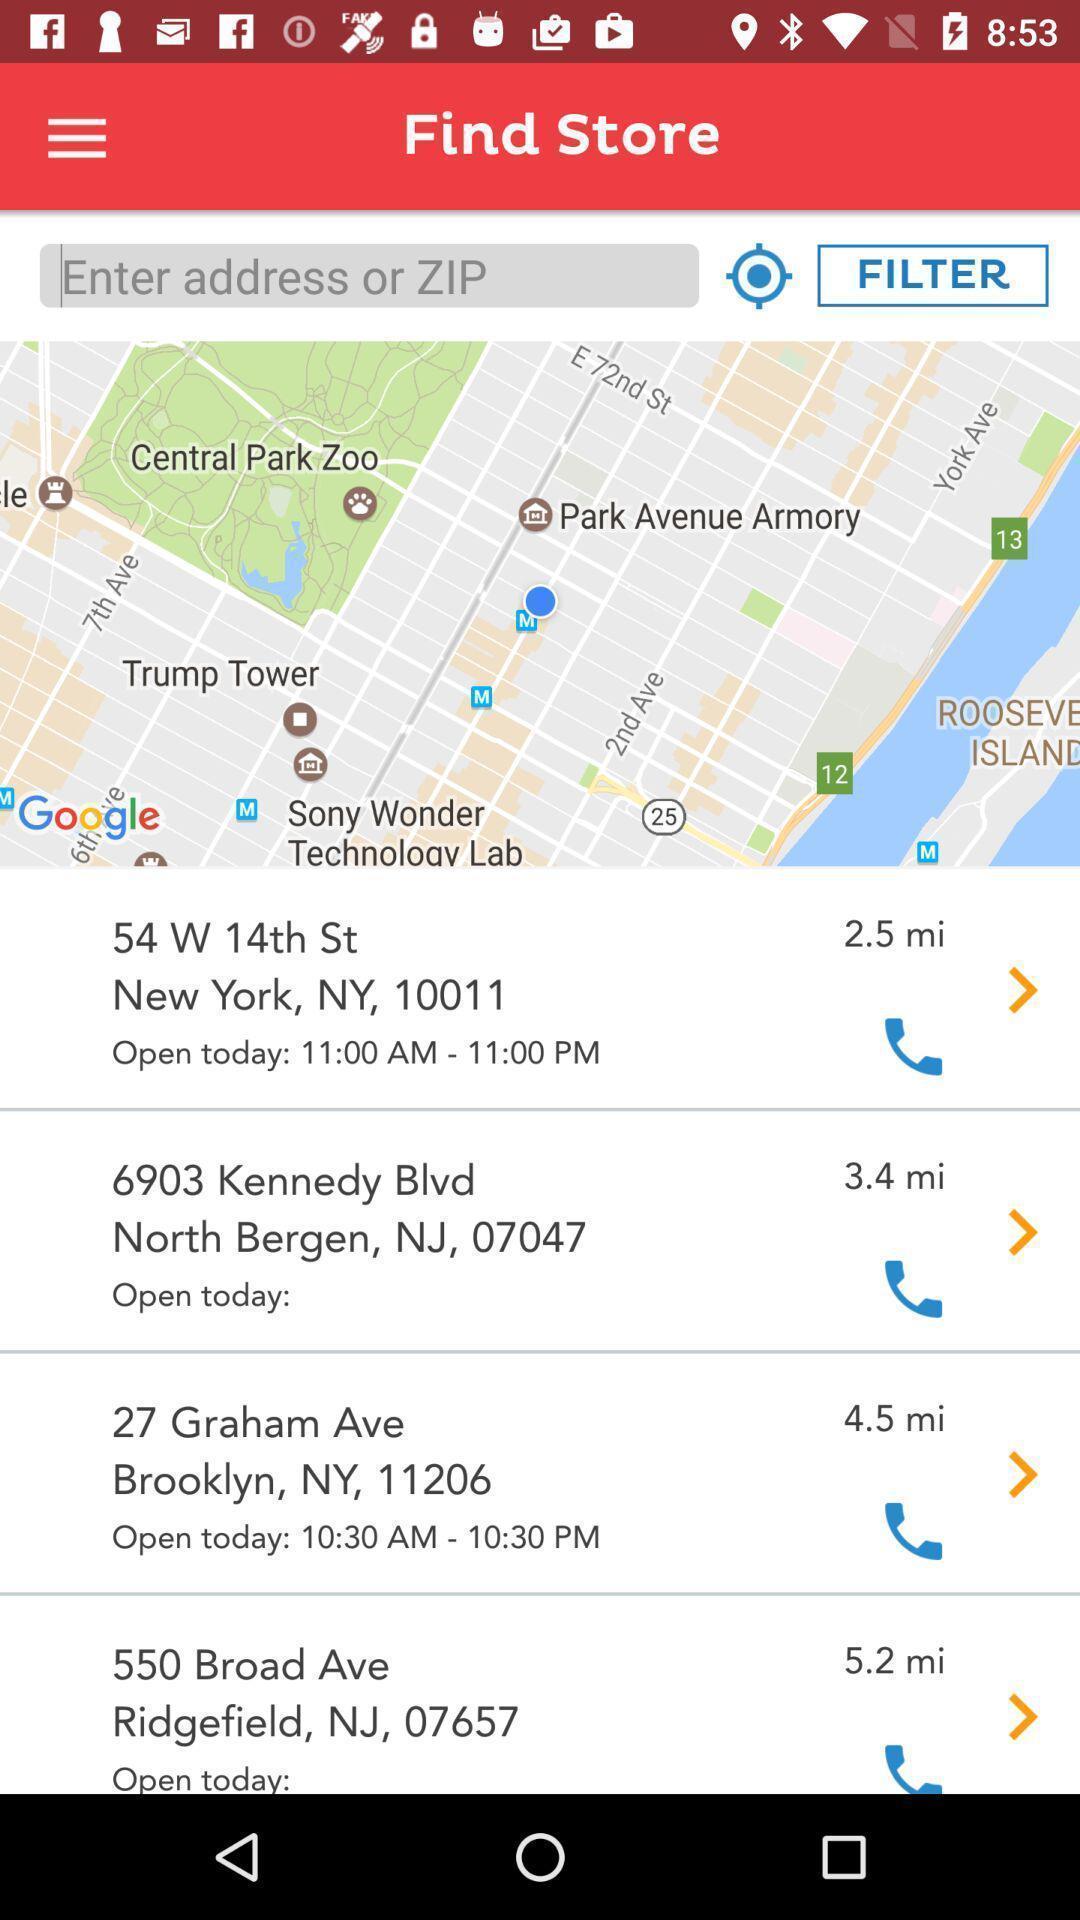Explain what's happening in this screen capture. Screen displaying the list of locations to find store. 